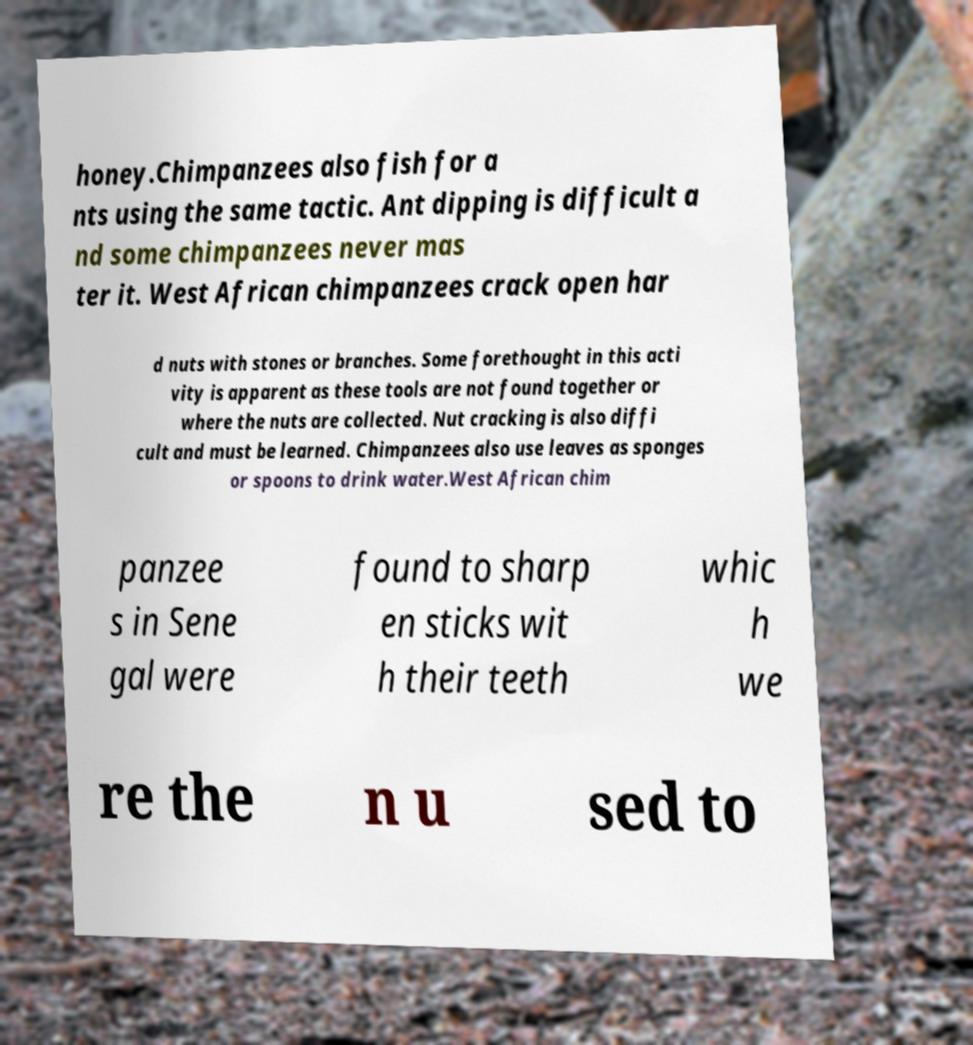Please read and relay the text visible in this image. What does it say? honey.Chimpanzees also fish for a nts using the same tactic. Ant dipping is difficult a nd some chimpanzees never mas ter it. West African chimpanzees crack open har d nuts with stones or branches. Some forethought in this acti vity is apparent as these tools are not found together or where the nuts are collected. Nut cracking is also diffi cult and must be learned. Chimpanzees also use leaves as sponges or spoons to drink water.West African chim panzee s in Sene gal were found to sharp en sticks wit h their teeth whic h we re the n u sed to 